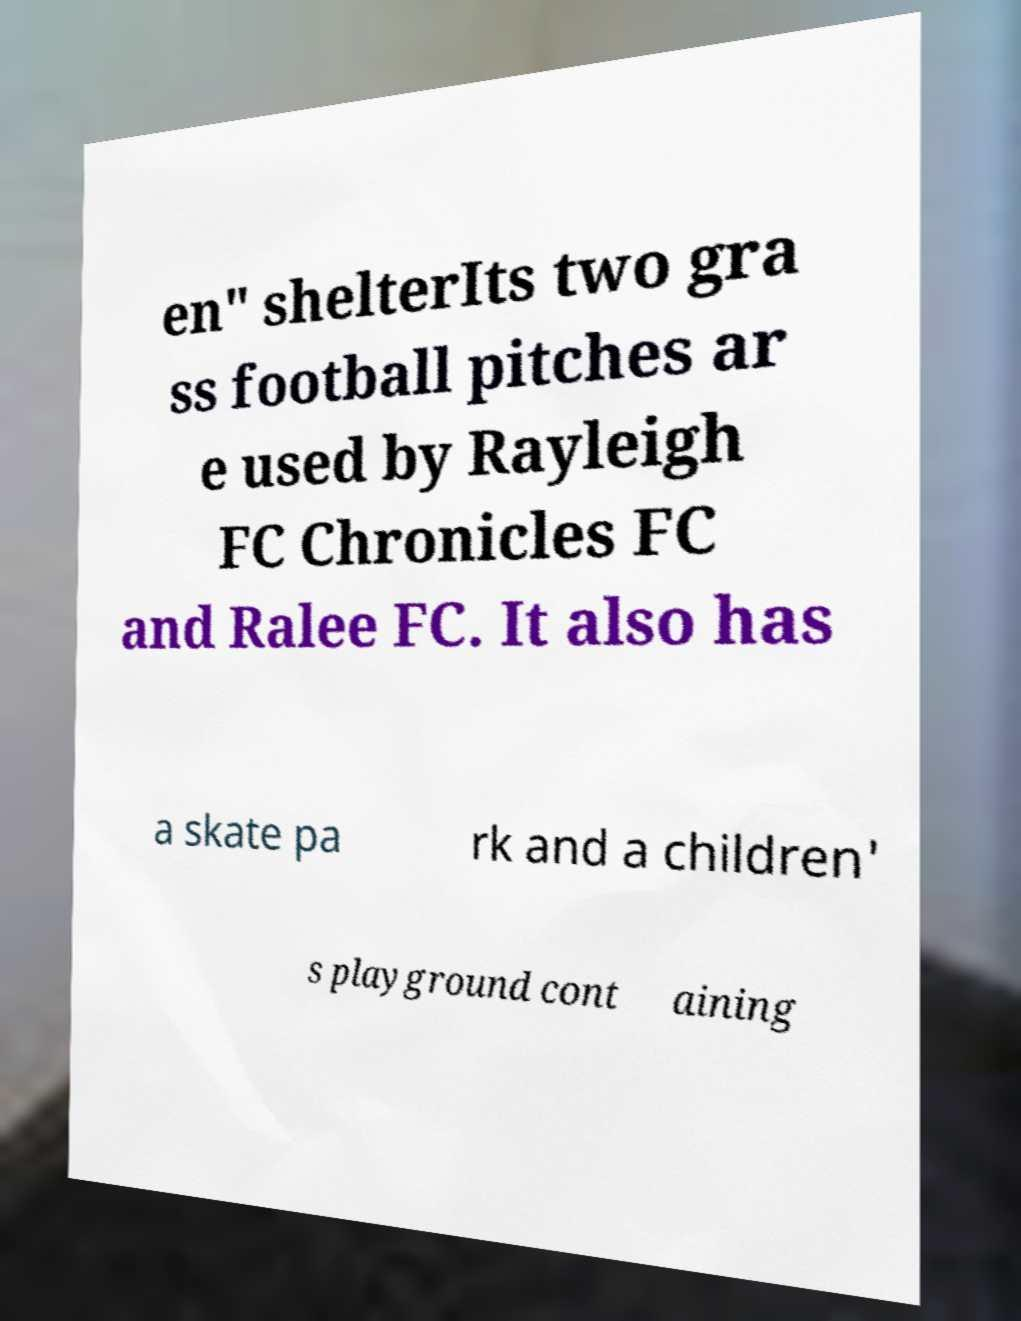What messages or text are displayed in this image? I need them in a readable, typed format. en" shelterIts two gra ss football pitches ar e used by Rayleigh FC Chronicles FC and Ralee FC. It also has a skate pa rk and a children' s playground cont aining 